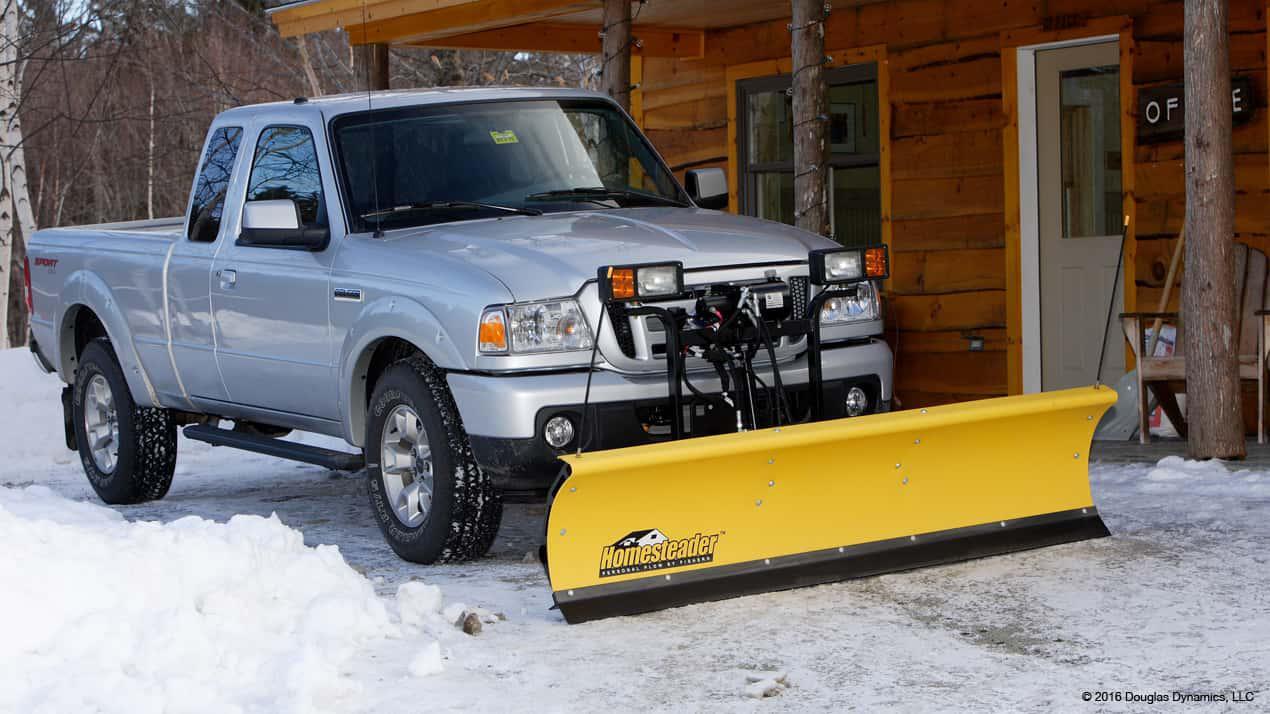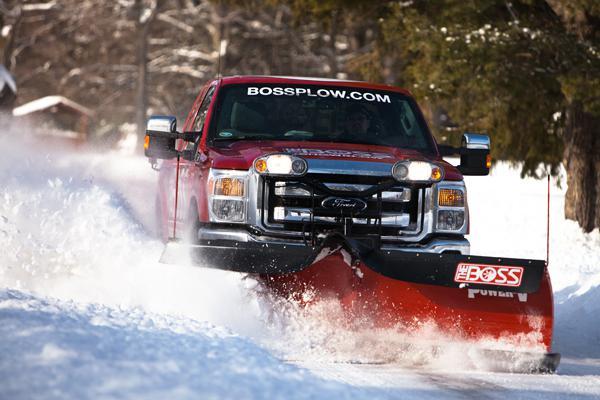The first image is the image on the left, the second image is the image on the right. Analyze the images presented: Is the assertion "there is at least one red truck in the image" valid? Answer yes or no. Yes. 